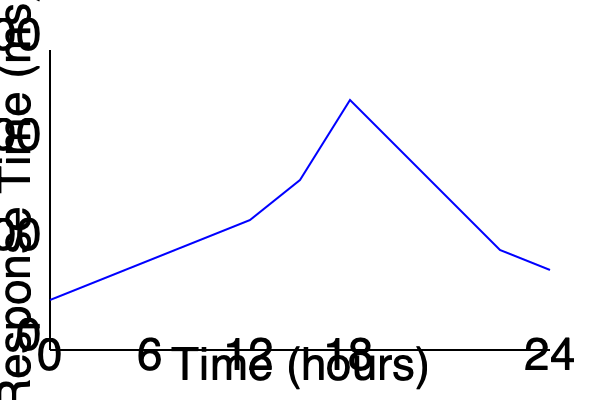Based on the server response time graph over 24 hours, at what time does the system experience the highest load, and what action would you recommend to mitigate potential performance issues? To answer this question, we need to analyze the graph and interpret the data:

1. The x-axis represents time over 24 hours, while the y-axis shows the response time in milliseconds.
2. A higher response time indicates a higher system load or potential performance issues.
3. Examining the graph, we can see that the response time peaks at around the 18-hour mark (6 PM).
4. This peak likely corresponds to the highest system load during the day.

To mitigate potential performance issues:

1. Identify the cause: The spike at 6 PM might be due to increased user activity or scheduled jobs.
2. Resource allocation: Consider increasing server resources during this peak time.
3. Load balancing: Implement or optimize load balancing to distribute traffic more evenly.
4. Caching: Enhance caching mechanisms to reduce database queries and improve response times.
5. Query optimization: Review and optimize database queries that might be causing slowdowns.
6. Monitoring: Set up Prometheus alerts for when response times exceed a certain threshold.

The recommended action would be to implement a combination of these strategies, focusing on increasing resources and optimizing performance during the peak hour around 6 PM.
Answer: Increase resources and optimize performance at 6 PM. 